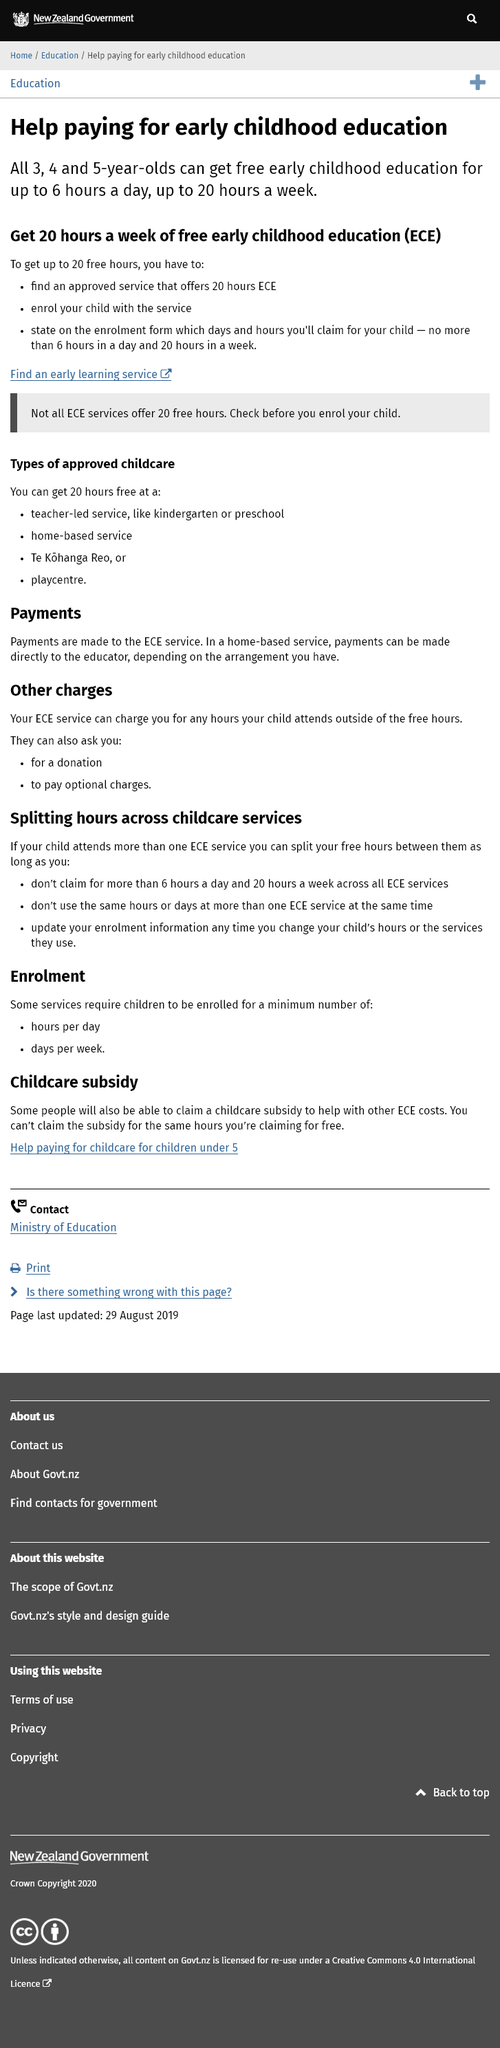Highlight a few significant elements in this photo. You can claim free early childhood education for up to 6 hours per day. It is mandatory for children to receive free early childhood education once they reach the age of three, four, or five years old. Up to 20 hours of free early childhood education per week is available for young children. 